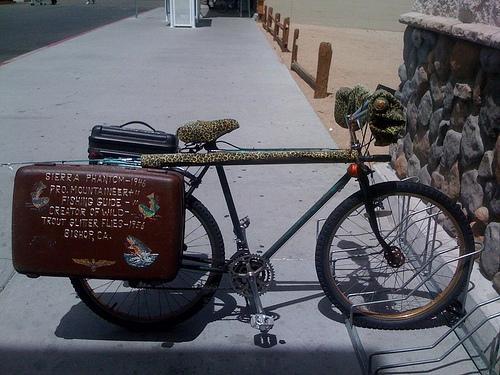What design is the bike seat? leopard 